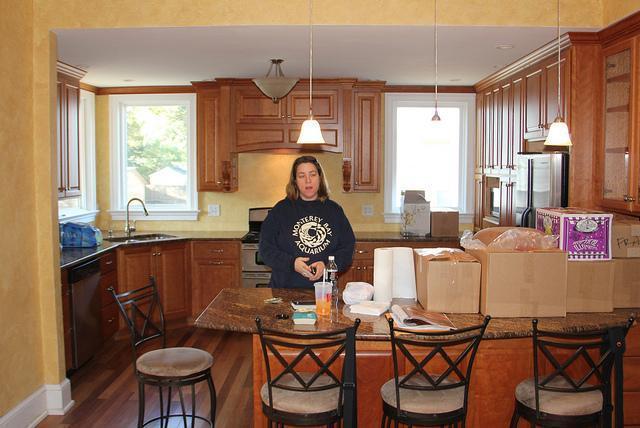How many chairs are seated around the bar top?
Give a very brief answer. 4. How many chairs are there?
Give a very brief answer. 4. 